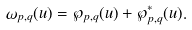<formula> <loc_0><loc_0><loc_500><loc_500>\omega _ { p , q } ( u ) = \wp _ { p , q } ( u ) + \wp ^ { * } _ { p , q } ( u ) .</formula> 